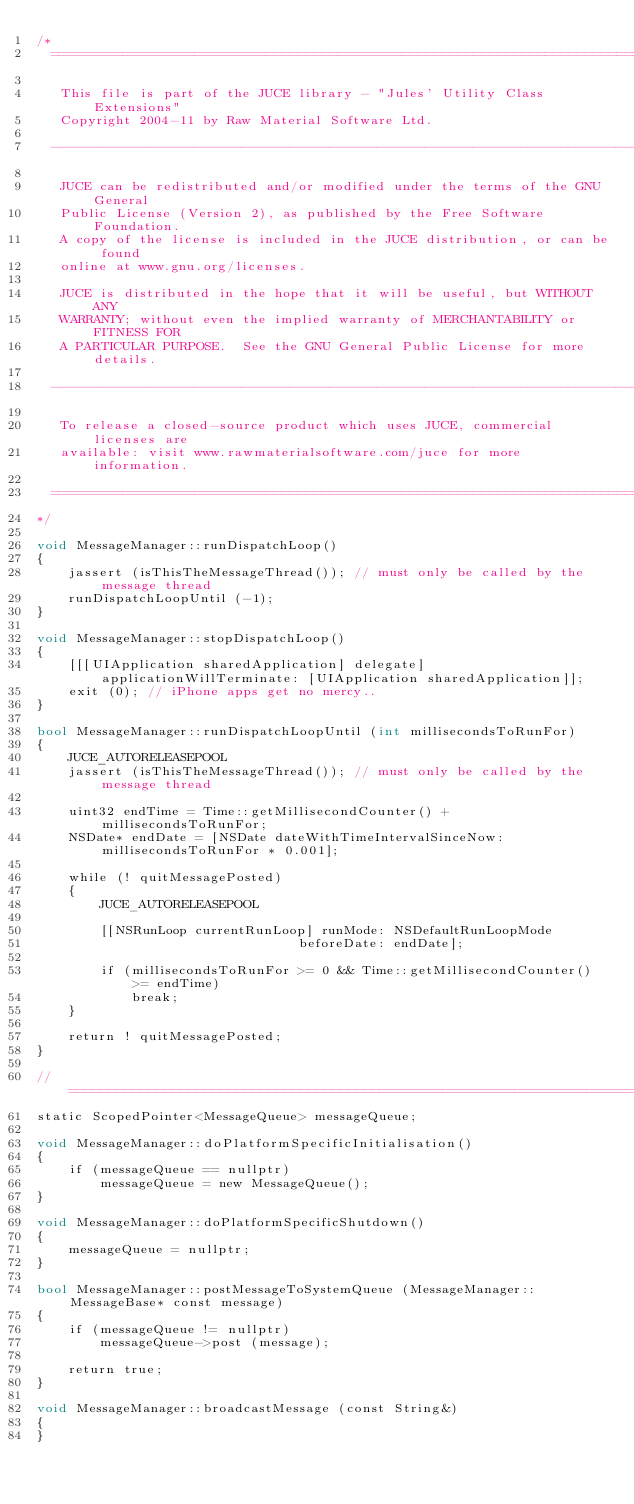<code> <loc_0><loc_0><loc_500><loc_500><_ObjectiveC_>/*
  ==============================================================================

   This file is part of the JUCE library - "Jules' Utility Class Extensions"
   Copyright 2004-11 by Raw Material Software Ltd.

  ------------------------------------------------------------------------------

   JUCE can be redistributed and/or modified under the terms of the GNU General
   Public License (Version 2), as published by the Free Software Foundation.
   A copy of the license is included in the JUCE distribution, or can be found
   online at www.gnu.org/licenses.

   JUCE is distributed in the hope that it will be useful, but WITHOUT ANY
   WARRANTY; without even the implied warranty of MERCHANTABILITY or FITNESS FOR
   A PARTICULAR PURPOSE.  See the GNU General Public License for more details.

  ------------------------------------------------------------------------------

   To release a closed-source product which uses JUCE, commercial licenses are
   available: visit www.rawmaterialsoftware.com/juce for more information.

  ==============================================================================
*/

void MessageManager::runDispatchLoop()
{
    jassert (isThisTheMessageThread()); // must only be called by the message thread
    runDispatchLoopUntil (-1);
}

void MessageManager::stopDispatchLoop()
{
    [[[UIApplication sharedApplication] delegate] applicationWillTerminate: [UIApplication sharedApplication]];
    exit (0); // iPhone apps get no mercy..
}

bool MessageManager::runDispatchLoopUntil (int millisecondsToRunFor)
{
    JUCE_AUTORELEASEPOOL
    jassert (isThisTheMessageThread()); // must only be called by the message thread

    uint32 endTime = Time::getMillisecondCounter() + millisecondsToRunFor;
    NSDate* endDate = [NSDate dateWithTimeIntervalSinceNow: millisecondsToRunFor * 0.001];

    while (! quitMessagePosted)
    {
        JUCE_AUTORELEASEPOOL

        [[NSRunLoop currentRunLoop] runMode: NSDefaultRunLoopMode
                                 beforeDate: endDate];

        if (millisecondsToRunFor >= 0 && Time::getMillisecondCounter() >= endTime)
            break;
    }

    return ! quitMessagePosted;
}

//==============================================================================
static ScopedPointer<MessageQueue> messageQueue;

void MessageManager::doPlatformSpecificInitialisation()
{
    if (messageQueue == nullptr)
        messageQueue = new MessageQueue();
}

void MessageManager::doPlatformSpecificShutdown()
{
    messageQueue = nullptr;
}

bool MessageManager::postMessageToSystemQueue (MessageManager::MessageBase* const message)
{
    if (messageQueue != nullptr)
        messageQueue->post (message);

    return true;
}

void MessageManager::broadcastMessage (const String&)
{
}
</code> 